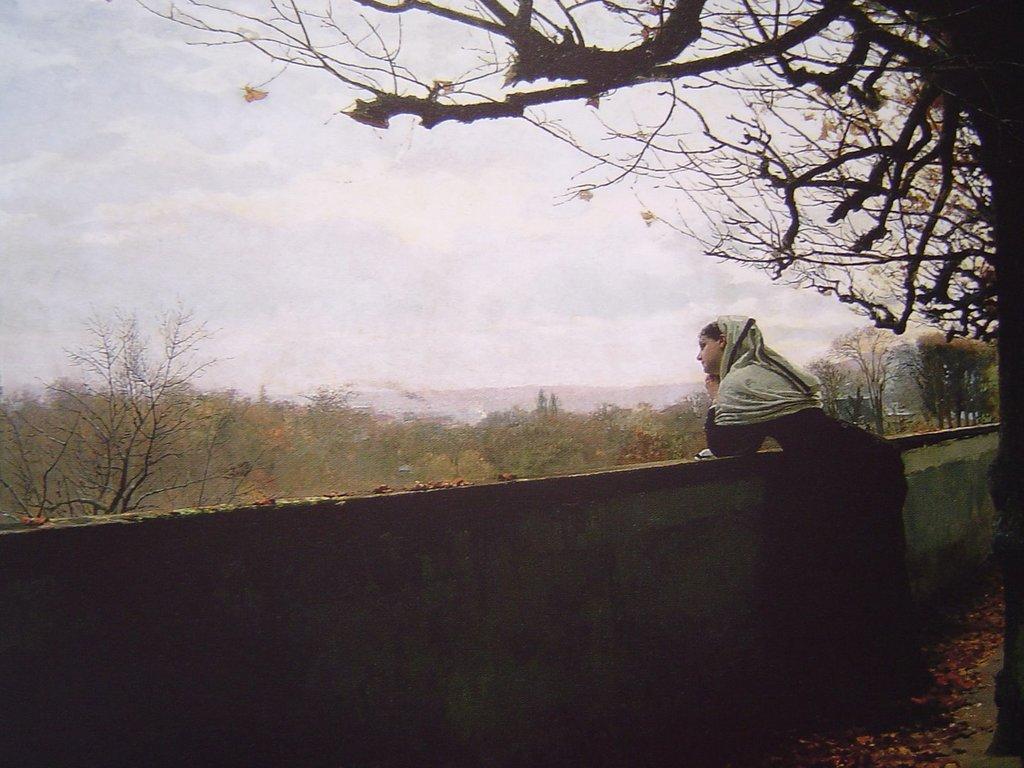Describe this image in one or two sentences. In this picture we can see a woman standing at the wall, dried leaves on the ground, trees and in the background we can see the sky. 